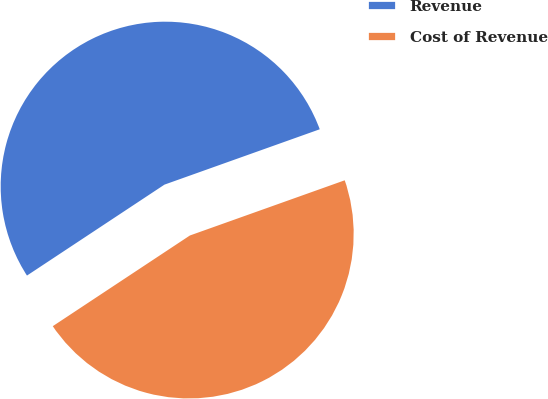Convert chart. <chart><loc_0><loc_0><loc_500><loc_500><pie_chart><fcel>Revenue<fcel>Cost of Revenue<nl><fcel>53.85%<fcel>46.15%<nl></chart> 